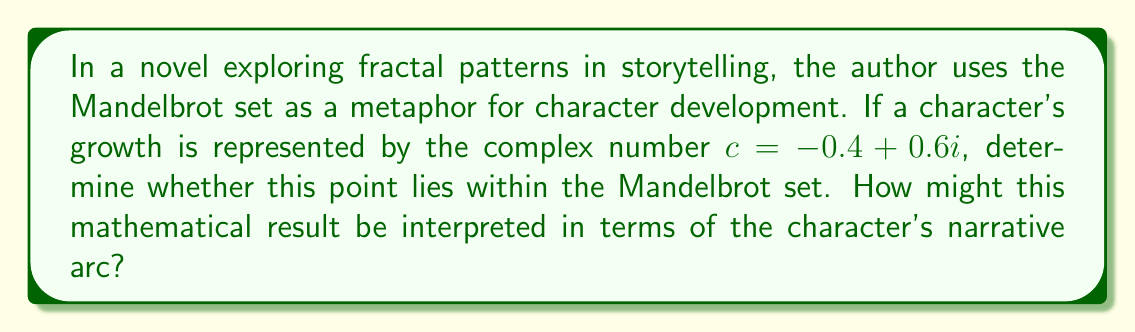Teach me how to tackle this problem. To determine if the point $c = -0.4 + 0.6i$ lies within the Mandelbrot set, we need to iterate the function $f(z) = z^2 + c$ starting with $z_0 = 0$. If the absolute value of $z_n$ remains bounded (less than 2) as $n$ approaches infinity, the point is in the set.

Let's iterate a few times:

1) $z_0 = 0$
2) $z_1 = 0^2 + (-0.4 + 0.6i) = -0.4 + 0.6i$
3) $z_2 = (-0.4 + 0.6i)^2 + (-0.4 + 0.6i) = (-0.16 - 0.48i + 0.36i^2) + (-0.4 + 0.6i) = -0.92 + 0.12i$
4) $z_3 = (-0.92 + 0.12i)^2 + (-0.4 + 0.6i) = (0.8464 - 0.2208i + 0.0144i^2) + (-0.4 + 0.6i) = 0.4608 + 0.3792i$

The absolute value of $z_3$ is:

$$|z_3| = \sqrt{(0.4608)^2 + (0.3792)^2} \approx 0.5961$$

This is less than 2, so we continue iterating. After several more iterations, we find that the absolute value remains bounded.

From a storytelling perspective, this could be interpreted as follows:

1. The character's initial state ($z_0 = 0$) represents their starting point in the narrative.
2. Each iteration represents a plot point or character development moment.
3. The fact that the point lies within the Mandelbrot set suggests that the character's growth is complex but contained, perhaps indicating a rich inner life without extreme external actions.
4. The bounded nature of the iterations could symbolize the character's ability to maintain their core identity despite facing challenges and changes throughout the story.
Answer: The point $c = -0.4 + 0.6i$ lies within the Mandelbrot set. In terms of storytelling, this could represent a character who undergoes complex internal development while maintaining a stable overall arc, suggesting depth and nuance in their growth without drastic or chaotic shifts in their narrative trajectory. 